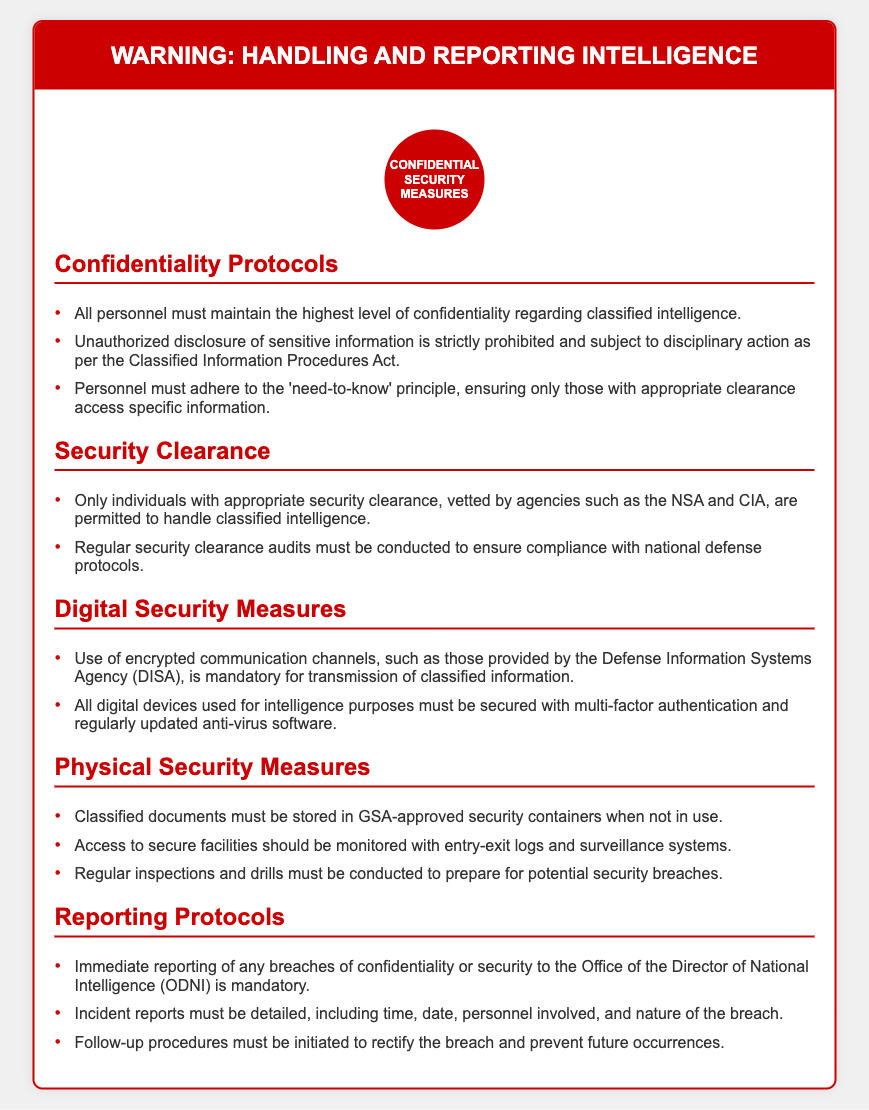What is the title of the document? The title of the document is prominently displayed at the top and calls attention to the subject matter, alerting readers to the nature of the content.
Answer: WARNING: Handling and Reporting Intelligence What must personnel maintain regarding classified intelligence? The document specifies an important responsibility of personnel involved with classified intelligence, emphasizing a key operational principle.
Answer: The highest level of confidentiality Who is allowed to handle classified intelligence? The document outlines clear guidelines regarding the access and handling of classified intelligence based on security protocols.
Answer: Individuals with appropriate security clearance What is mandatory for the transmission of classified information? This requirement is crucial for ensuring secure communication in compliance with security measures, as stated in the document.
Answer: Encrypted communication channels What should be stored in GSA-approved security containers? The document specifies what must be securely stored when not in use to protect sensitive information, highlighting the physical security measures in place.
Answer: Classified documents What must be reported immediately? The document emphasizes an important action that must be taken in response to specific incidents, underpinning the importance of security.
Answer: Breaches of confidentiality or security How often should security clearance audits be conducted? This question pertains to the regulatory practices outlined in the document, which are necessary to ensure ongoing compliance.
Answer: Regularly What should incident reports include? The document details the necessary information that must be documented in reports following specific incidents, ensuring thorough accountability.
Answer: Time, date, personnel involved, and nature of the breach What type of security systems should be used in secure facilities? The document points out essential measures needed for monitoring unique environments handling classified information.
Answer: Surveillance systems 